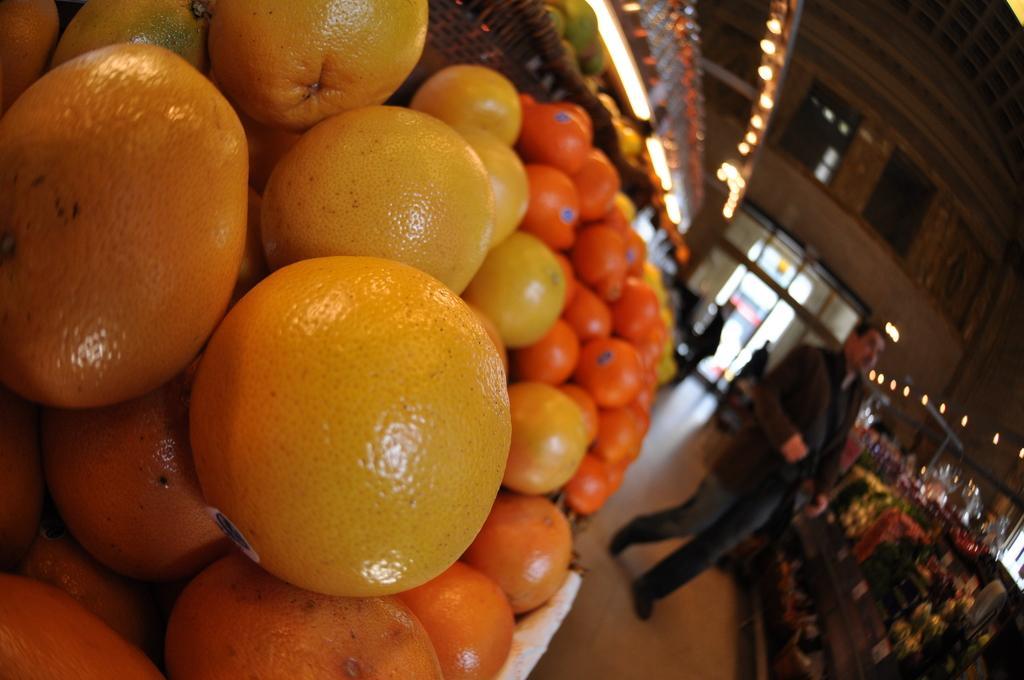In one or two sentences, can you explain what this image depicts? In this image we can see a store. There are many fruits in the store. There are few people in the image. There is a door in the image. There are many lights in the image. 